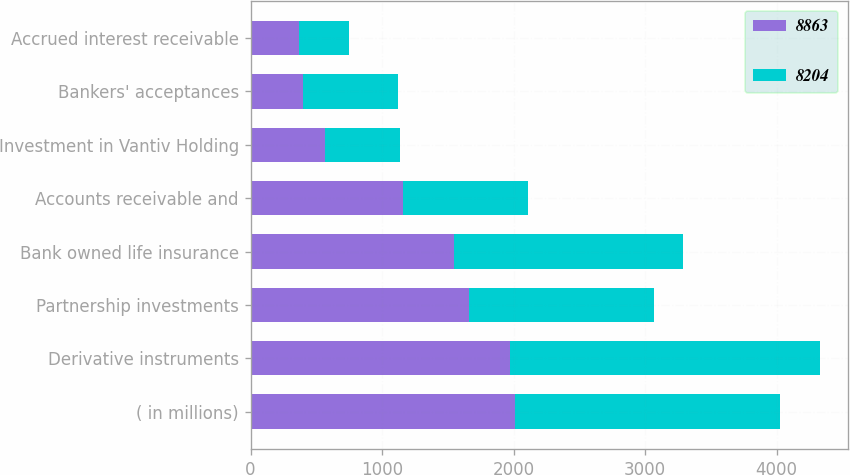Convert chart to OTSL. <chart><loc_0><loc_0><loc_500><loc_500><stacked_bar_chart><ecel><fcel>( in millions)<fcel>Derivative instruments<fcel>Partnership investments<fcel>Bank owned life insurance<fcel>Accounts receivable and<fcel>Investment in Vantiv Holding<fcel>Bankers' acceptances<fcel>Accrued interest receivable<nl><fcel>8863<fcel>2012<fcel>1972<fcel>1657<fcel>1547<fcel>1155<fcel>563<fcel>398<fcel>369<nl><fcel>8204<fcel>2011<fcel>2356<fcel>1413<fcel>1742<fcel>955<fcel>576<fcel>726<fcel>382<nl></chart> 